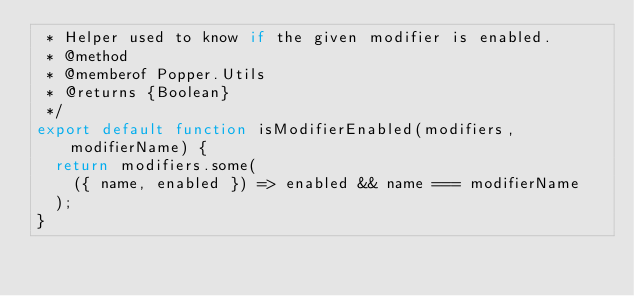Convert code to text. <code><loc_0><loc_0><loc_500><loc_500><_JavaScript_> * Helper used to know if the given modifier is enabled.
 * @method
 * @memberof Popper.Utils
 * @returns {Boolean}
 */
export default function isModifierEnabled(modifiers, modifierName) {
  return modifiers.some(
    ({ name, enabled }) => enabled && name === modifierName
  );
}
</code> 